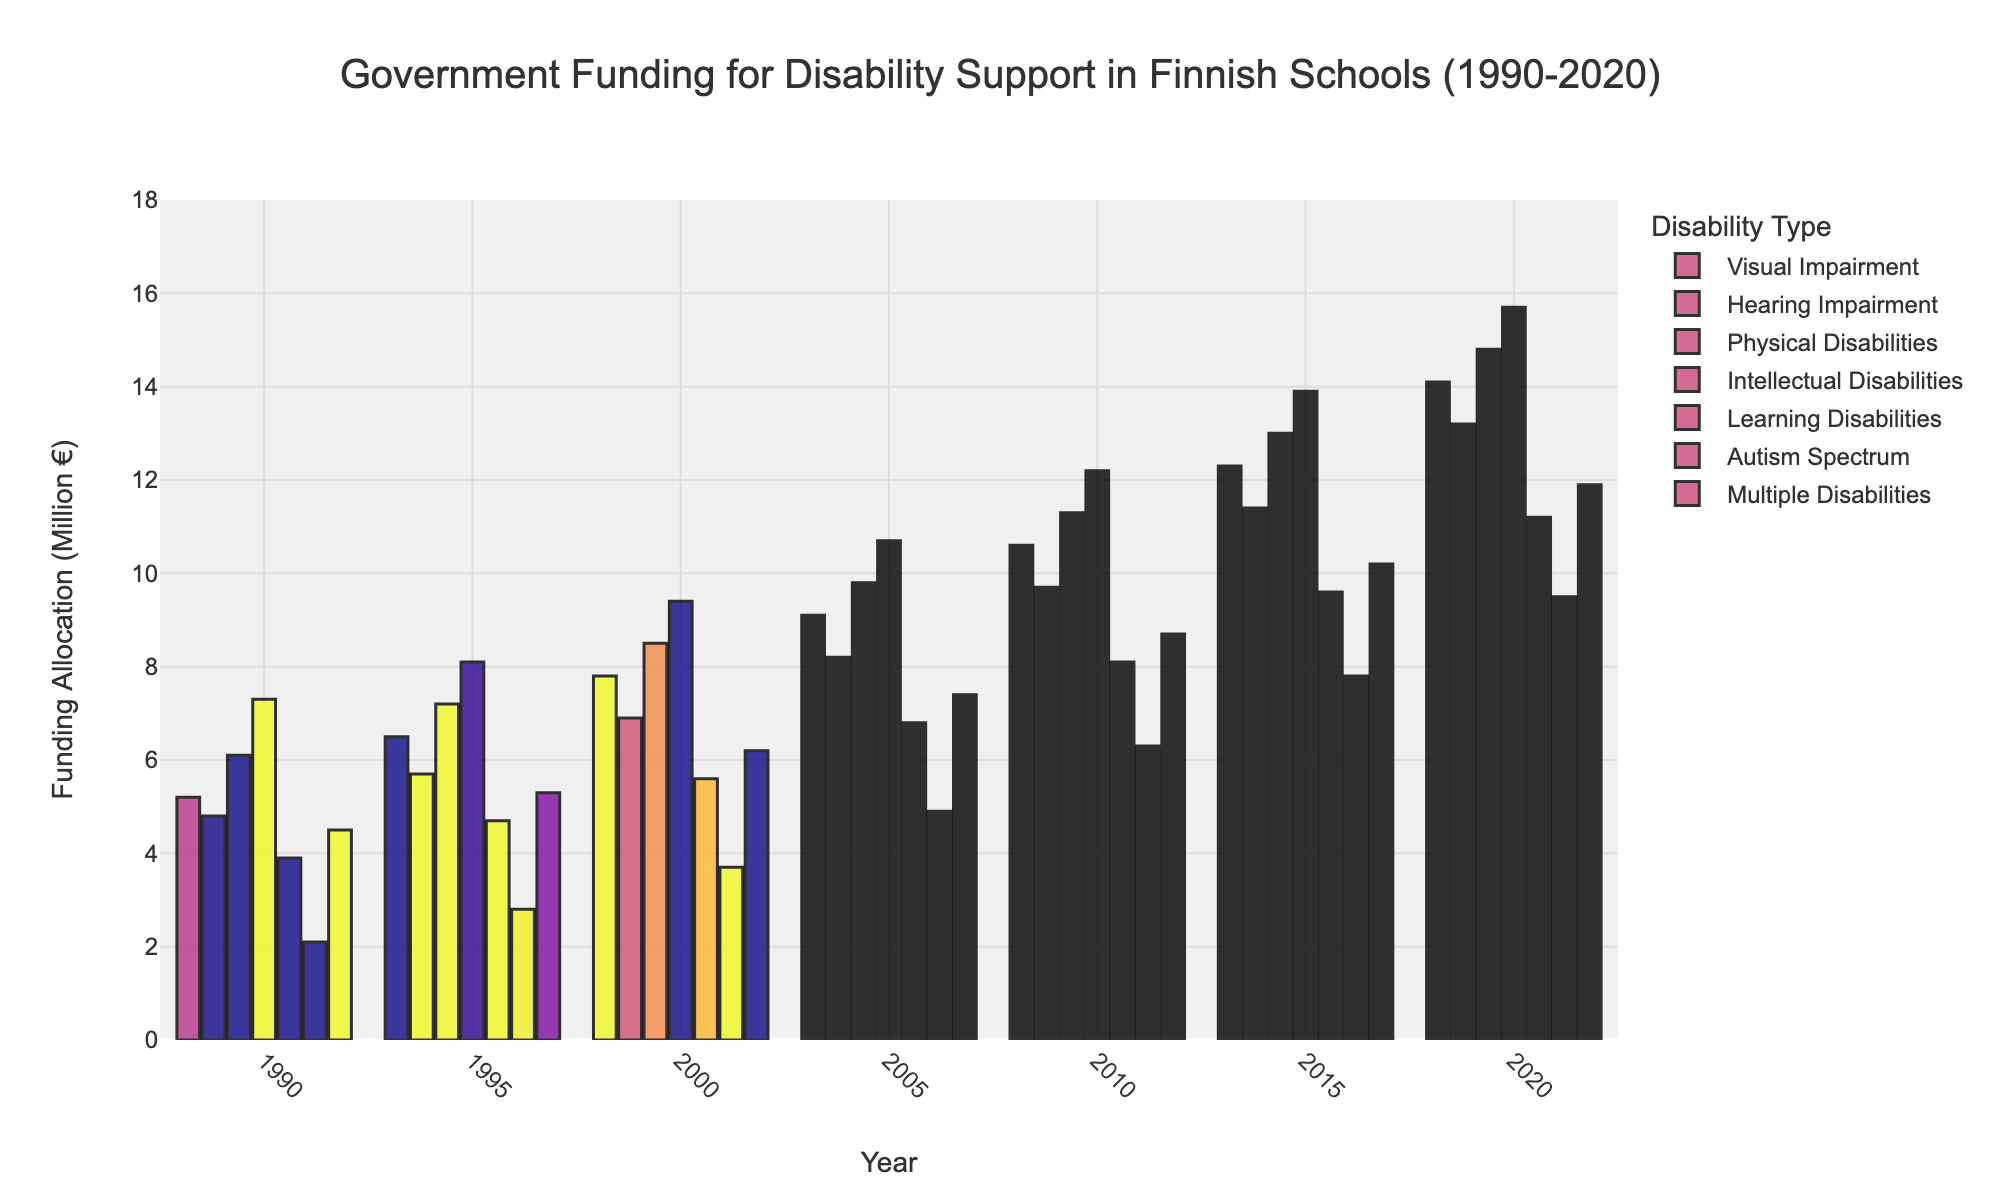What was the funding allocation for Physical Disabilities in 2020? Look at the bar representing Physical Disabilities for the year 2020 on the chart. The height corresponds to 14.8 million euros.
Answer: 14.8 million euros Which year saw the funding for Autism Spectrum cross the 5 million euro mark for the first time? Find the point where the funding for Autism Spectrum exceeds 5 million euros by identifying the bar height that first surpasses this amount. This occurs between 2000 and 2005, and it is first above 5 million in the year 2005.
Answer: 2005 What is the difference in funding between Visual Impairment and Intellectual Disabilities in 1990? Find the heights of the bars for Visual Impairment and Intellectual Disabilities in 1990. Visual Impairment is 5.2 million euros and Intellectual Disabilities is 7.3 million euros. The difference is 7.3 - 5.2 = 2.1 million euros.
Answer: 2.1 million euros What is the average funding allocation for Multiple Disabilities from 1990 to 2020? Sum the values of Multiple Disabilities for each year (4.5 + 5.3 + 6.2 + 7.4 + 8.7 + 10.2 + 11.9 = 54.2 million euros) and divide by the number of years (7). The average is 54.2 / 7 ≈ 7.74 million euros.
Answer: 7.74 million euros Did the government ever allocate more than 10 million euros to Learning Disabilities before 2015? Examine the bar heights for Learning Disabilities for the years before 2015. The funding first exceeds 10 million euros only in 2020, so it did not exceed 10 million euros before 2015.
Answer: No Which disability type saw the greatest absolute increase in funding from 1990 to 2020? Calculate the difference in funding from 1990 to 2020 for each disability type: Visual Impairment (14.1 - 5.2 = 8.9), Hearing Impairment (13.2 - 4.8 = 8.4), Physical Disabilities (14.8 - 6.1 = 8.7), Intellectual Disabilities (15.7 - 7.3 = 8.4), Learning Disabilities (11.2 - 3.9 = 7.3), Autism Spectrum (9.5 - 2.1 = 7.4), Multiple Disabilities (11.9 - 4.5 = 7.4). The greatest increase is in Visual Impairment, with an increase of 8.9 million euros.
Answer: Visual Impairment What trend do you observe in the funding allocation for Multiple Disabilities from 1990 to 2020? Look at the bars representing Multiple Disabilities over the years. The heights show a steady increase from 4.5 million euros in 1990 to 11.9 million euros in 2020.
Answer: Steady increase Across all disability types, which year showed the maximum overall funding allocation? Sum the heights of all category bars for each year and identify the year with the highest total. The sums are: 1990 (33.9 million euros), 1995 (40.3), 2000 (48.1), 2005 (56.9), 2010 (67.5), 2015 (78.2), 2020 (90.4). The highest is in 2020 with 90.4 million euros.
Answer: 2020 Compare the funding allocation for Learning Disabilities and Autism Spectrum in the year 2010. Which one was higher? Find the bars for Learning Disabilities and Autism Spectrum in 2010. The heights are 8.1 million euros for Learning Disabilities and 6.3 million euros for Autism Spectrum. Learning Disabilities has a higher allocation.
Answer: Learning Disabilities 